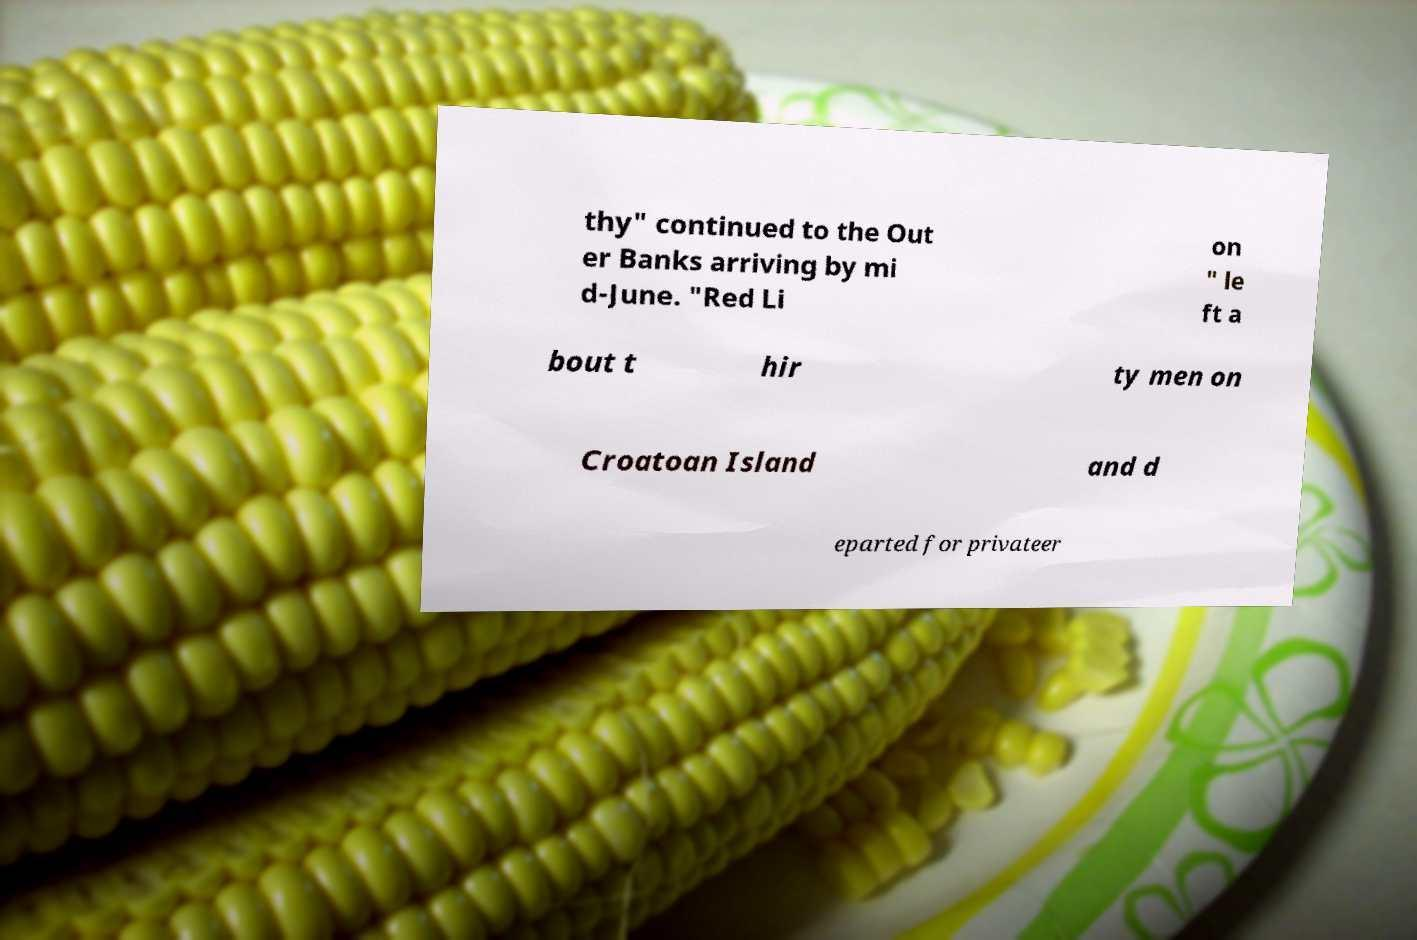I need the written content from this picture converted into text. Can you do that? thy" continued to the Out er Banks arriving by mi d-June. "Red Li on " le ft a bout t hir ty men on Croatoan Island and d eparted for privateer 